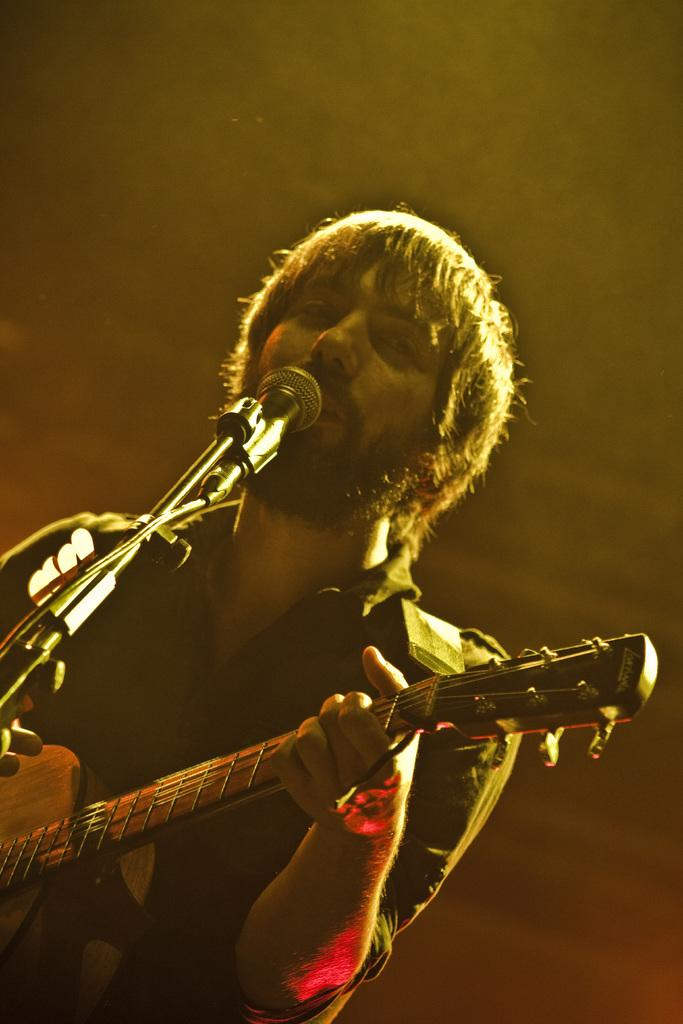What is the man in the image doing? The man is singing and playing a guitar. What object is the man using to amplify his voice? There is a microphone in the image. Reasoning: Leting: Let's think step by step in order to produce the conversation. We start by identifying the main subject in the image, which is the man. Then, we describe the actions he is performing, which are singing and playing a guitar. Finally, we mention the presence of a microphone, which is related to the man's singing. Absurd Question/Answer: What type of knee surgery is the man undergoing in the image? There is no indication of a knee surgery or any medical procedure in the image; the man is singing and playing a guitar. 